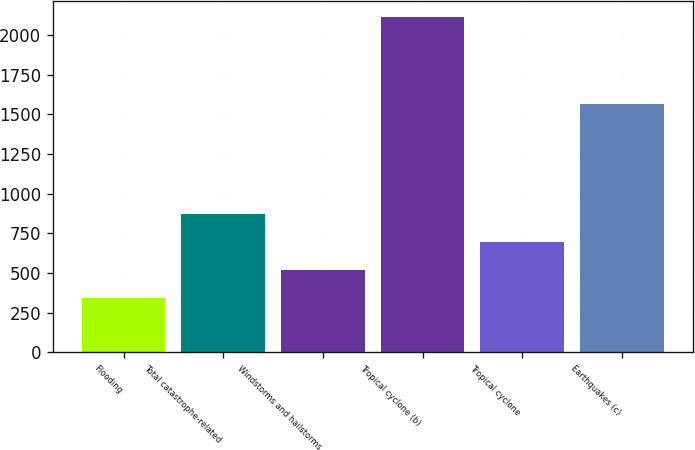Convert chart to OTSL. <chart><loc_0><loc_0><loc_500><loc_500><bar_chart><fcel>Flooding<fcel>Total catastrophe-related<fcel>Windstorms and hailstorms<fcel>Tropical cyclone (b)<fcel>Tropical cyclone<fcel>Earthquakes (c)<nl><fcel>345<fcel>875.1<fcel>521.7<fcel>2112<fcel>698.4<fcel>1568<nl></chart> 